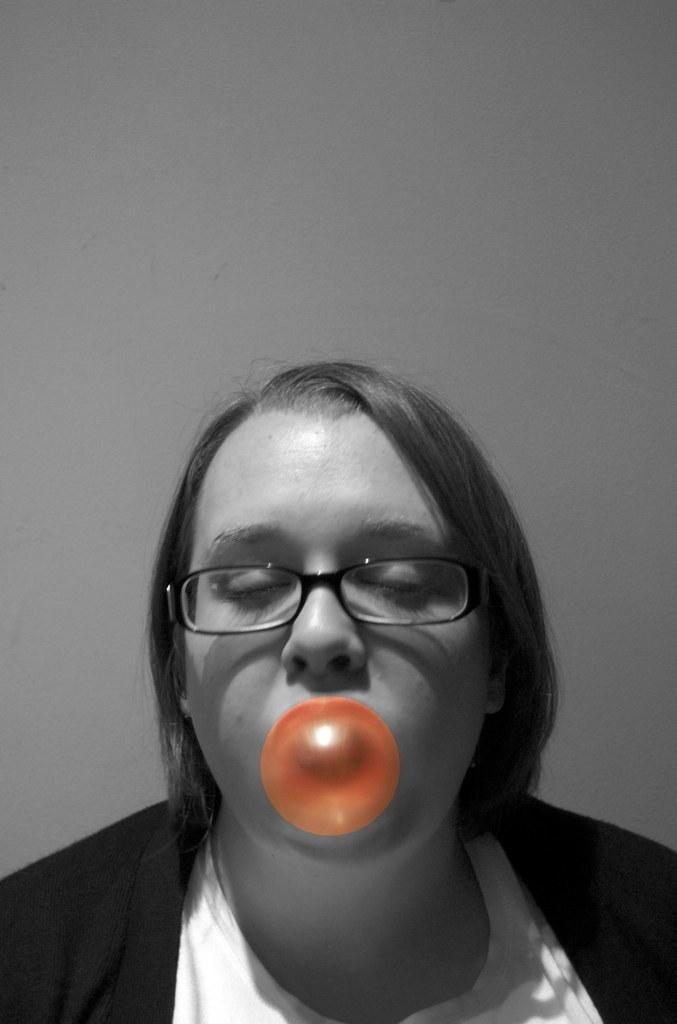Can you describe this image briefly? This is an edited image. In this image we can see a woman blowing a bubble gum. On the backside we can see a wall. 